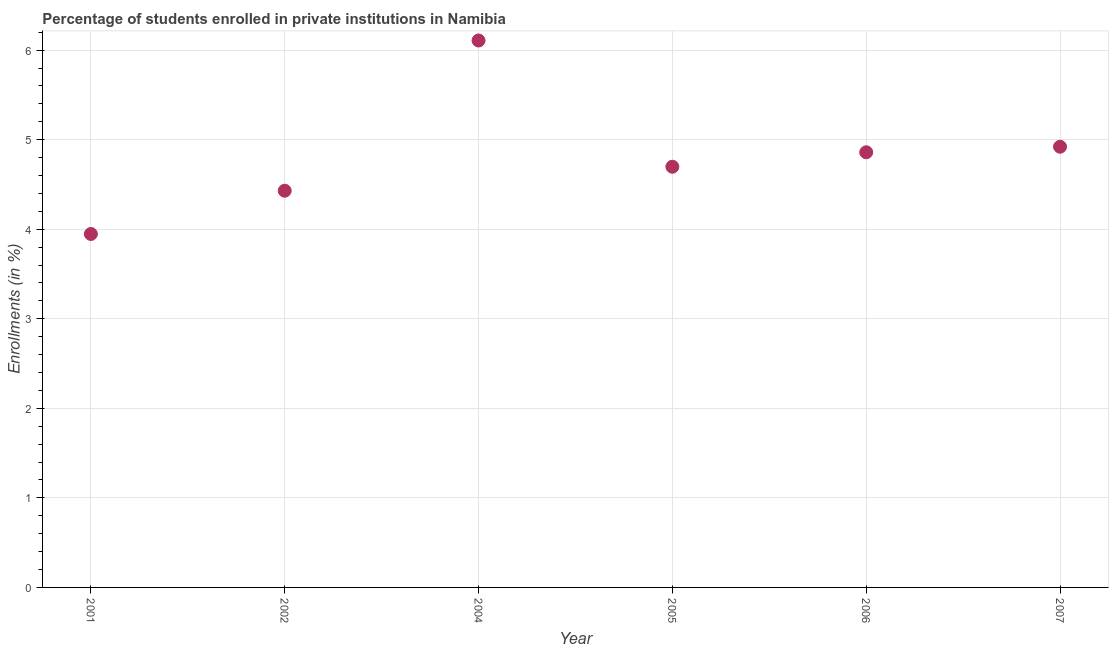What is the enrollments in private institutions in 2007?
Give a very brief answer. 4.92. Across all years, what is the maximum enrollments in private institutions?
Make the answer very short. 6.11. Across all years, what is the minimum enrollments in private institutions?
Offer a terse response. 3.95. What is the sum of the enrollments in private institutions?
Provide a succinct answer. 28.96. What is the difference between the enrollments in private institutions in 2006 and 2007?
Give a very brief answer. -0.06. What is the average enrollments in private institutions per year?
Offer a terse response. 4.83. What is the median enrollments in private institutions?
Your response must be concise. 4.78. Do a majority of the years between 2001 and 2004 (inclusive) have enrollments in private institutions greater than 2.8 %?
Provide a succinct answer. Yes. What is the ratio of the enrollments in private institutions in 2005 to that in 2007?
Provide a succinct answer. 0.95. Is the enrollments in private institutions in 2002 less than that in 2005?
Your response must be concise. Yes. What is the difference between the highest and the second highest enrollments in private institutions?
Keep it short and to the point. 1.19. Is the sum of the enrollments in private institutions in 2002 and 2005 greater than the maximum enrollments in private institutions across all years?
Keep it short and to the point. Yes. What is the difference between the highest and the lowest enrollments in private institutions?
Your answer should be very brief. 2.16. In how many years, is the enrollments in private institutions greater than the average enrollments in private institutions taken over all years?
Keep it short and to the point. 3. Does the enrollments in private institutions monotonically increase over the years?
Offer a very short reply. No. Are the values on the major ticks of Y-axis written in scientific E-notation?
Make the answer very short. No. Does the graph contain any zero values?
Provide a short and direct response. No. What is the title of the graph?
Offer a terse response. Percentage of students enrolled in private institutions in Namibia. What is the label or title of the Y-axis?
Provide a short and direct response. Enrollments (in %). What is the Enrollments (in %) in 2001?
Provide a short and direct response. 3.95. What is the Enrollments (in %) in 2002?
Make the answer very short. 4.43. What is the Enrollments (in %) in 2004?
Provide a succinct answer. 6.11. What is the Enrollments (in %) in 2005?
Your response must be concise. 4.7. What is the Enrollments (in %) in 2006?
Your response must be concise. 4.86. What is the Enrollments (in %) in 2007?
Ensure brevity in your answer.  4.92. What is the difference between the Enrollments (in %) in 2001 and 2002?
Your answer should be very brief. -0.48. What is the difference between the Enrollments (in %) in 2001 and 2004?
Offer a very short reply. -2.16. What is the difference between the Enrollments (in %) in 2001 and 2005?
Provide a short and direct response. -0.75. What is the difference between the Enrollments (in %) in 2001 and 2006?
Provide a succinct answer. -0.91. What is the difference between the Enrollments (in %) in 2001 and 2007?
Provide a succinct answer. -0.97. What is the difference between the Enrollments (in %) in 2002 and 2004?
Ensure brevity in your answer.  -1.68. What is the difference between the Enrollments (in %) in 2002 and 2005?
Your response must be concise. -0.27. What is the difference between the Enrollments (in %) in 2002 and 2006?
Provide a succinct answer. -0.43. What is the difference between the Enrollments (in %) in 2002 and 2007?
Keep it short and to the point. -0.49. What is the difference between the Enrollments (in %) in 2004 and 2005?
Your response must be concise. 1.41. What is the difference between the Enrollments (in %) in 2004 and 2006?
Offer a very short reply. 1.25. What is the difference between the Enrollments (in %) in 2004 and 2007?
Keep it short and to the point. 1.19. What is the difference between the Enrollments (in %) in 2005 and 2006?
Offer a terse response. -0.16. What is the difference between the Enrollments (in %) in 2005 and 2007?
Provide a succinct answer. -0.22. What is the difference between the Enrollments (in %) in 2006 and 2007?
Ensure brevity in your answer.  -0.06. What is the ratio of the Enrollments (in %) in 2001 to that in 2002?
Give a very brief answer. 0.89. What is the ratio of the Enrollments (in %) in 2001 to that in 2004?
Provide a succinct answer. 0.65. What is the ratio of the Enrollments (in %) in 2001 to that in 2005?
Your answer should be very brief. 0.84. What is the ratio of the Enrollments (in %) in 2001 to that in 2006?
Keep it short and to the point. 0.81. What is the ratio of the Enrollments (in %) in 2001 to that in 2007?
Provide a short and direct response. 0.8. What is the ratio of the Enrollments (in %) in 2002 to that in 2004?
Give a very brief answer. 0.72. What is the ratio of the Enrollments (in %) in 2002 to that in 2005?
Your answer should be compact. 0.94. What is the ratio of the Enrollments (in %) in 2002 to that in 2006?
Make the answer very short. 0.91. What is the ratio of the Enrollments (in %) in 2002 to that in 2007?
Your answer should be compact. 0.9. What is the ratio of the Enrollments (in %) in 2004 to that in 2006?
Offer a terse response. 1.26. What is the ratio of the Enrollments (in %) in 2004 to that in 2007?
Keep it short and to the point. 1.24. What is the ratio of the Enrollments (in %) in 2005 to that in 2007?
Your response must be concise. 0.95. 